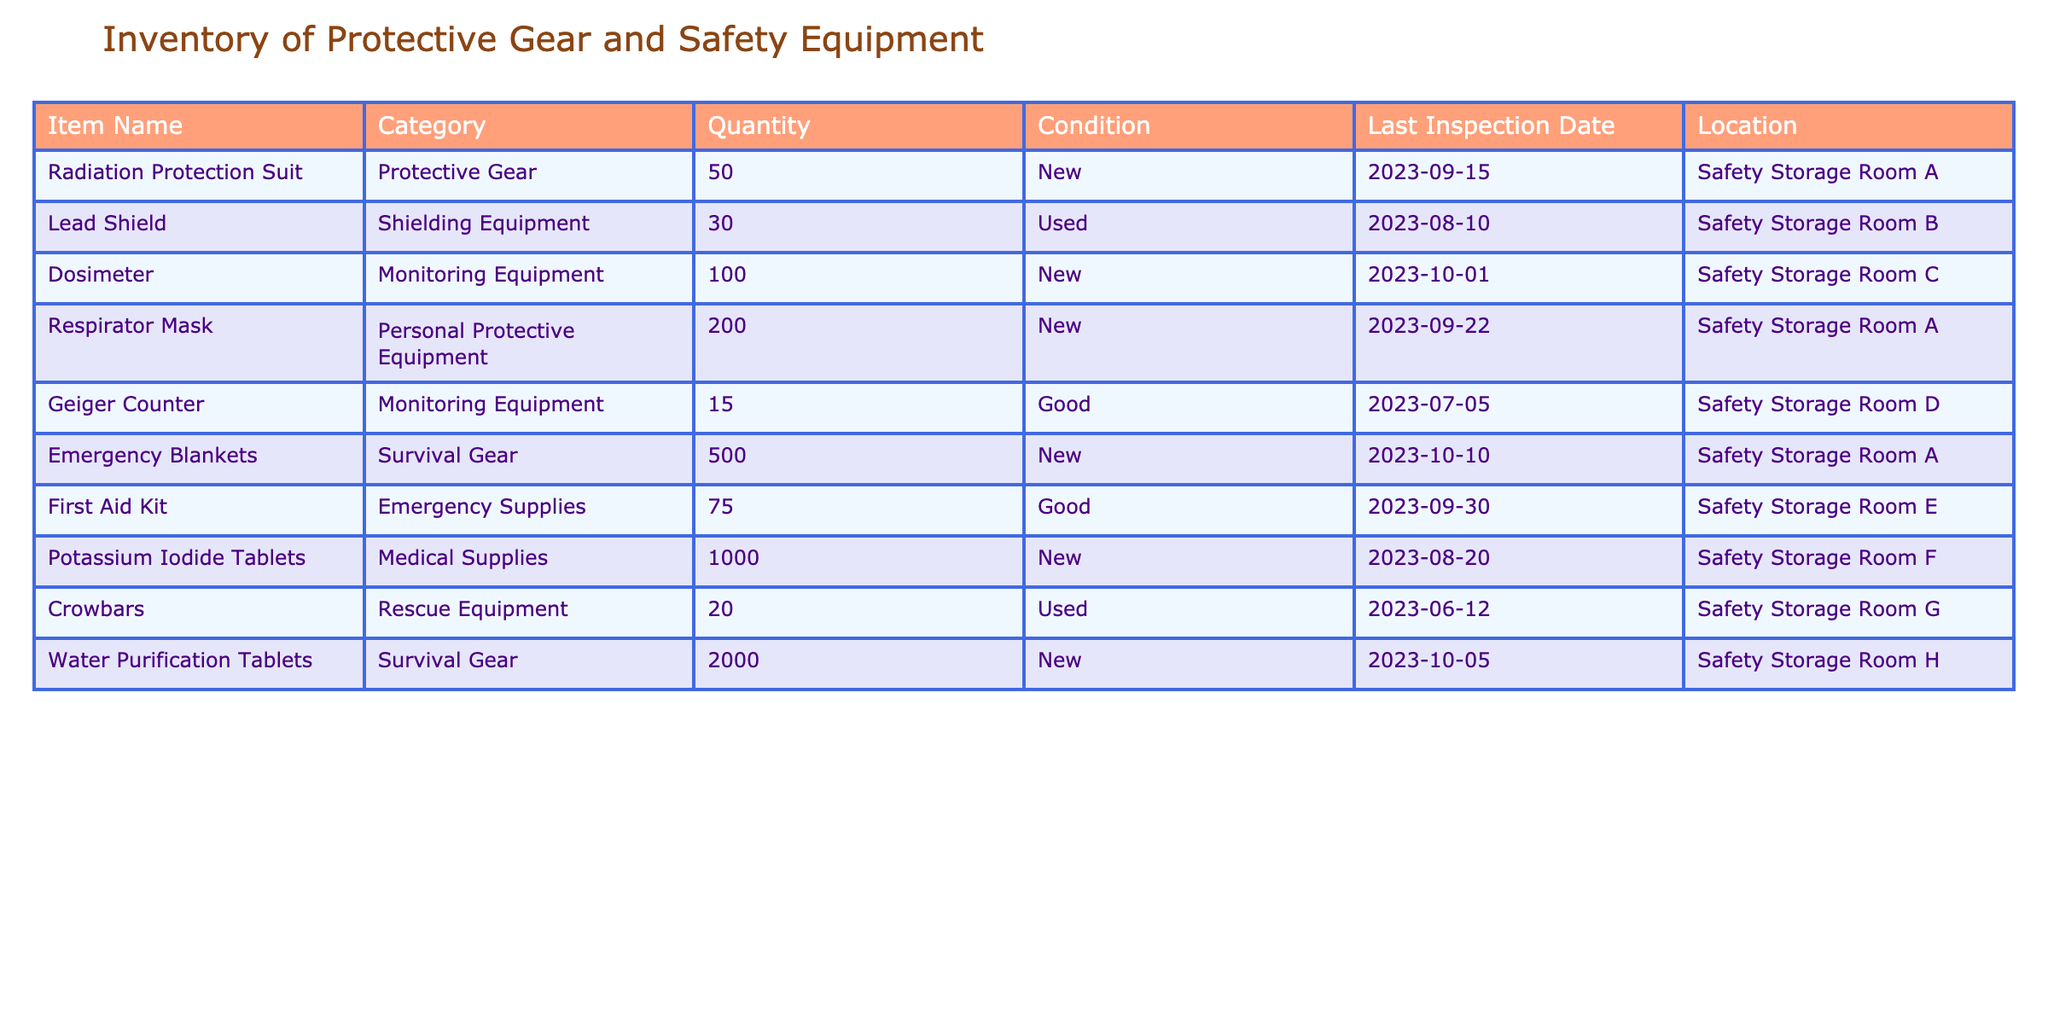What is the total quantity of Potassium Iodide Tablets? The table lists 1000 Potassium Iodide Tablets under the Medical Supplies category. Hence, the total quantity is directly provided in the table.
Answer: 1000 How many items in the inventory are classified as New? By analyzing the conditions in the table, we see that the items "Radiation Protection Suit," "Dosimeter," "Respirator Mask," "Emergency Blankets," and "Potassium Iodide Tablets" are marked as New. This totals 5 items.
Answer: 5 What is the only equipment that has a quantity of more than 2000? The table shows that the quantity of Water Purification Tablets is 2000, making it the only equipment with a quantity over 2000.
Answer: Water Purification Tablets Are there any used items in the inventory? The table includes "Lead Shield" and "Crowbars" as used items. Hence, the answer is yes, indicating the presence of used equipment.
Answer: Yes What is the total quantity of Emergency Supplies? The table indicates that the only Emergency Supplies listed is the First Aid Kit, which has a quantity of 75. Thus, the total for this category is 75.
Answer: 75 Which location has the highest number of items available? We need to compare the quantities by location. "Safety Storage Room A" has 50 + 200 + 500 = 750 items. "Safety Storage Room H" has 2000, and none other exceed these sums. Thus, "Safety Storage Room H" has the highest at 2000.
Answer: Safety Storage Room H How many Geiger Counters are in good condition? The table states there are 15 Geiger Counters and it is marked as in good condition. Thus, the quantity remains as 15.
Answer: 15 What is the average quantity of Monitoring Equipment in the inventory? There are two Monitoring Equipment items: Dosimeter with 100 and Geiger Counter with 15. The total quantity is 115, and the average is calculated by dividing this total by 2 (the number of items), resulting in an average of 57.5.
Answer: 57.5 How many items in the 'Rescue Equipment' category are marked as "Used"? The table lists "Crowbars" in the Rescue Equipment category, and it is marked as used with a quantity of 20. Thus, it is the only used item in this category.
Answer: 1 